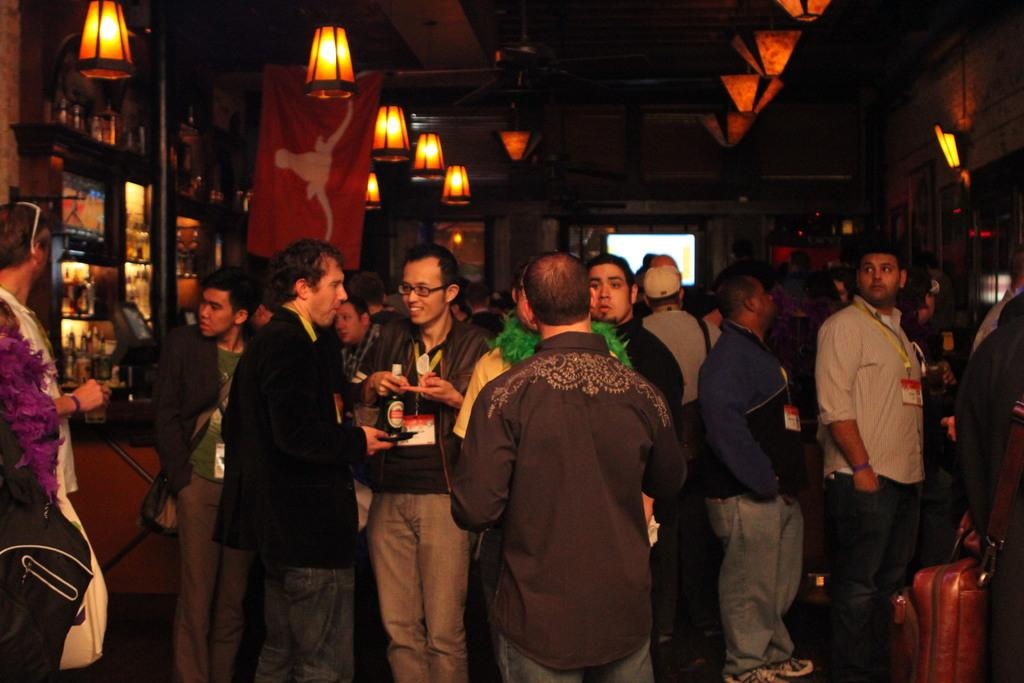What can be seen in the image? There are people standing in the image. Where are the people standing? The people are standing on the floor. What can be observed about the background of the image? The background of the image is dark, and there are shelves, a flag, and ceiling lights present. What type of vessel is being used by the wren in the image? There is no wren or vessel present in the image. Can you tell me where the church is located in the image? There is no church present in the image. 